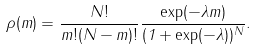Convert formula to latex. <formula><loc_0><loc_0><loc_500><loc_500>\rho ( m ) = \frac { N ! } { m ! ( N - m ) ! } \frac { \exp ( - \lambda m ) } { ( 1 + \exp ( - \lambda ) ) ^ { N } } .</formula> 